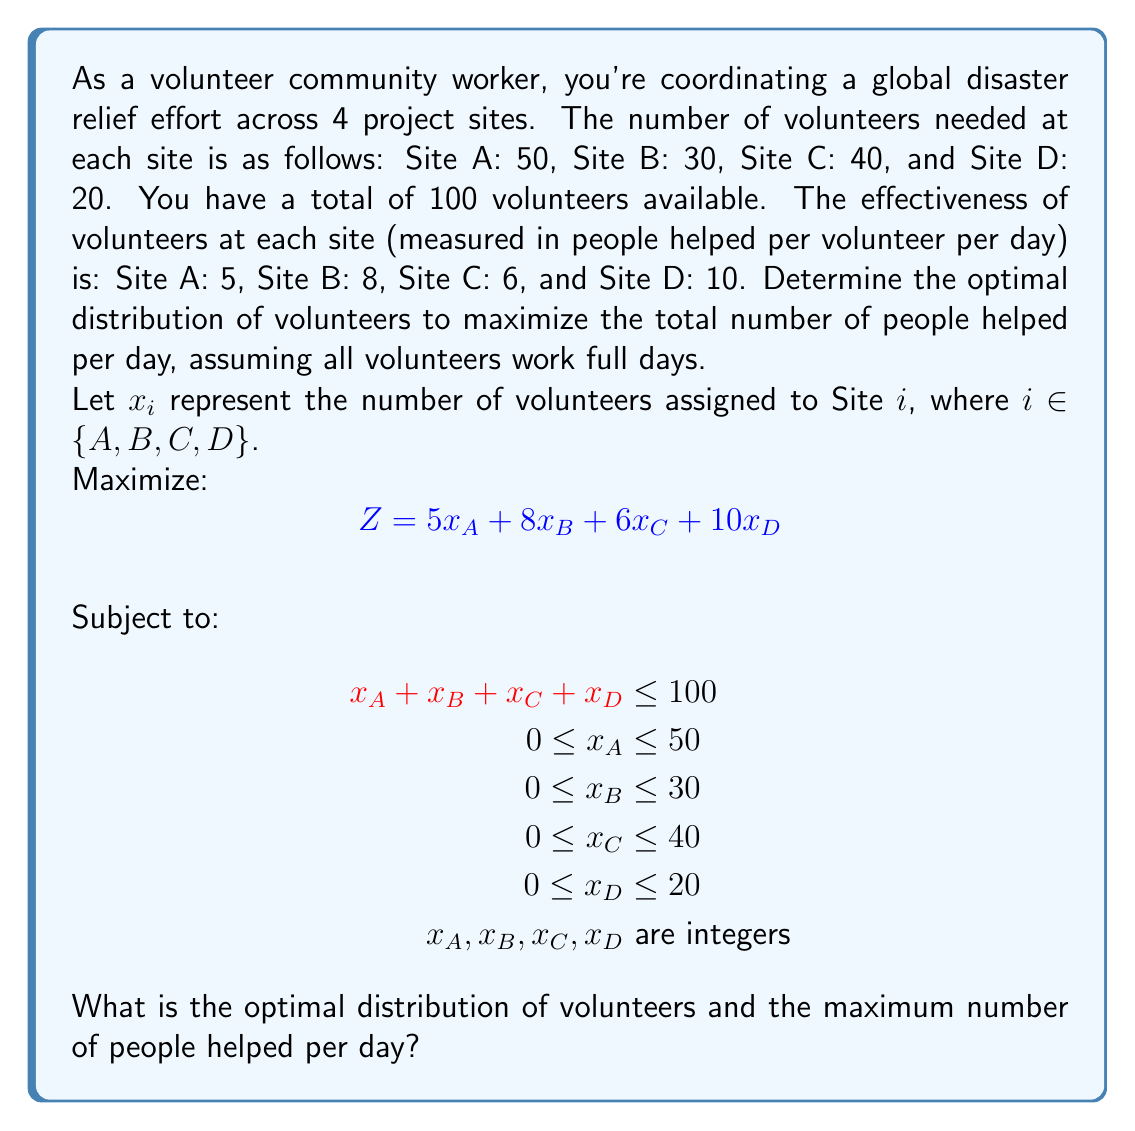Can you answer this question? This problem is an integer linear programming problem. We can solve it using the following steps:

1) First, we note that the objective function coefficients (effectiveness rates) are in descending order: Site D (10), Site B (8), Site C (6), and Site A (5).

2) To maximize the objective function, we should allocate volunteers to the sites in order of decreasing effectiveness, up to each site's maximum capacity or until we run out of volunteers.

3) Let's allocate volunteers in this order:

   Site D: Allocate 20 volunteers (maximum capacity)
   Remaining volunteers: 100 - 20 = 80

   Site B: Allocate 30 volunteers (maximum capacity)
   Remaining volunteers: 80 - 30 = 50

   Site C: Allocate 40 volunteers (maximum capacity)
   Remaining volunteers: 50 - 40 = 10

   Site A: Allocate the remaining 10 volunteers

4) The final allocation is:
   $x_D = 20$, $x_B = 30$, $x_C = 40$, $x_A = 10$

5) We can verify that this solution satisfies all constraints:
   Total volunteers used: 20 + 30 + 40 + 10 = 100 ≤ 100
   All site-specific constraints are satisfied

6) Calculate the objective function value:
   $Z = 5(10) + 8(30) + 6(40) + 10(20)$
   $Z = 50 + 240 + 240 + 200 = 730$

Therefore, the optimal distribution is 10 volunteers to Site A, 30 to Site B, 40 to Site C, and 20 to Site D. This distribution will help a maximum of 730 people per day.
Answer: Optimal distribution: Site A: 10, Site B: 30, Site C: 40, Site D: 20
Maximum number of people helped per day: 730 